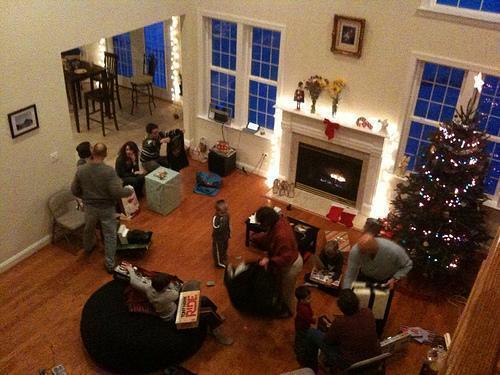What can often be found under the tree seen here?
Choose the correct response, then elucidate: 'Answer: answer
Rationale: rationale.'
Options: Mice, elves, dogs, gifts. Answer: gifts.
Rationale: The tree is a christmas tree and tradition has people and maybe even santa putting presents under the tree to be opened christmas morning. 